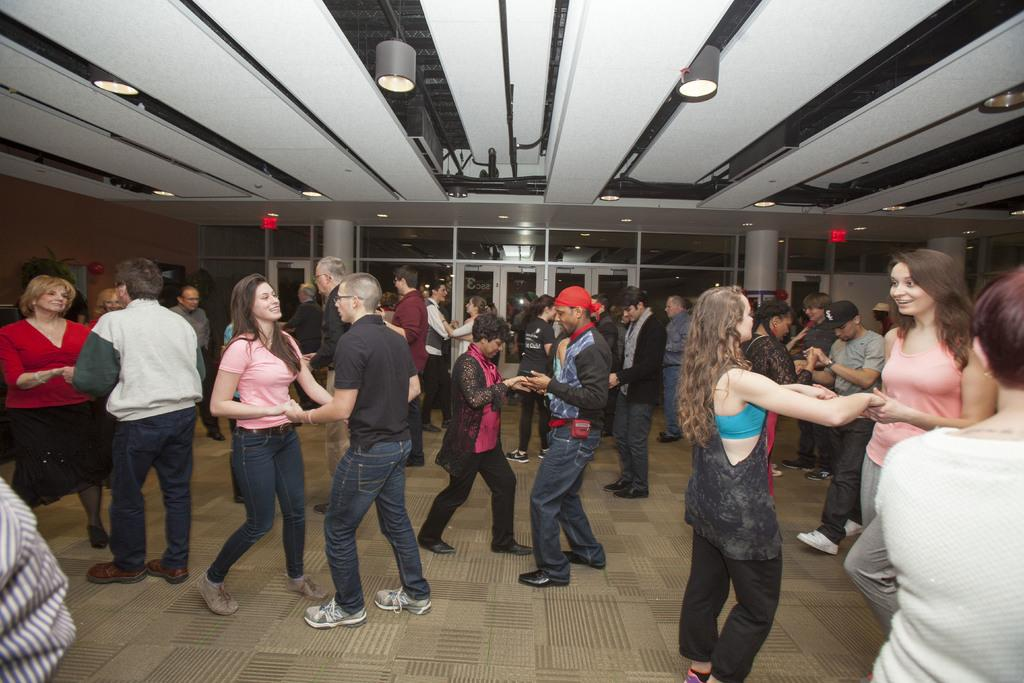What are the people in the image doing? There are many persons dancing in the image. Where is the dancing taking place? The dancing is taking place on the floor. What can be seen in the background of the image? There are doors and pillars in the background of the image. What is visible at the top of the image? Lights are visible at the top of the image. What type of cracker is being passed around during the dance in the image? There is no cracker present in the image; the people are dancing. How does the throat of the person dancing in the image feel? There is no information about the throat of any person in the image, as the focus is on their dancing. 